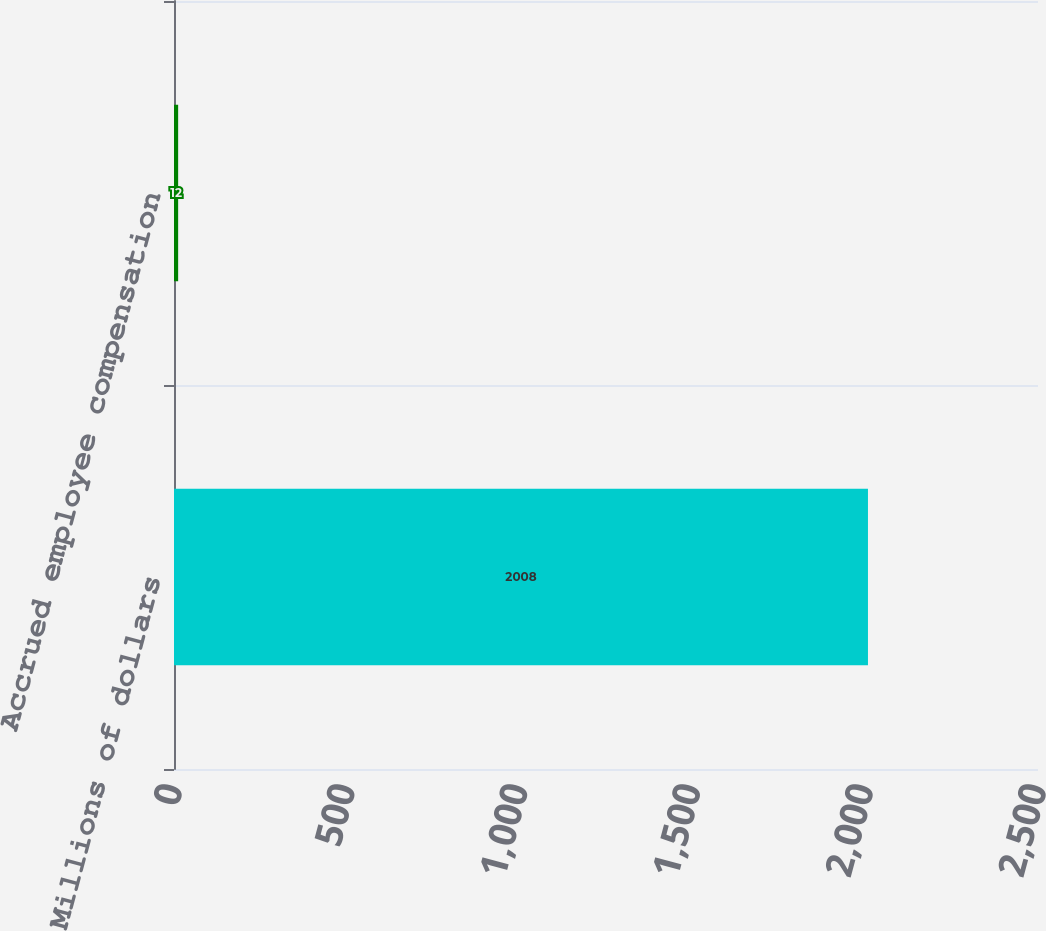<chart> <loc_0><loc_0><loc_500><loc_500><bar_chart><fcel>Millions of dollars<fcel>Accrued employee compensation<nl><fcel>2008<fcel>12<nl></chart> 